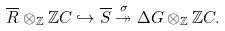<formula> <loc_0><loc_0><loc_500><loc_500>\overline { R } \otimes _ { \mathbb { Z } } \mathbb { Z } C \hookrightarrow \overline { S } \overset { \sigma } { \twoheadrightarrow } \Delta G \otimes _ { \mathbb { Z } } \mathbb { Z } C .</formula> 